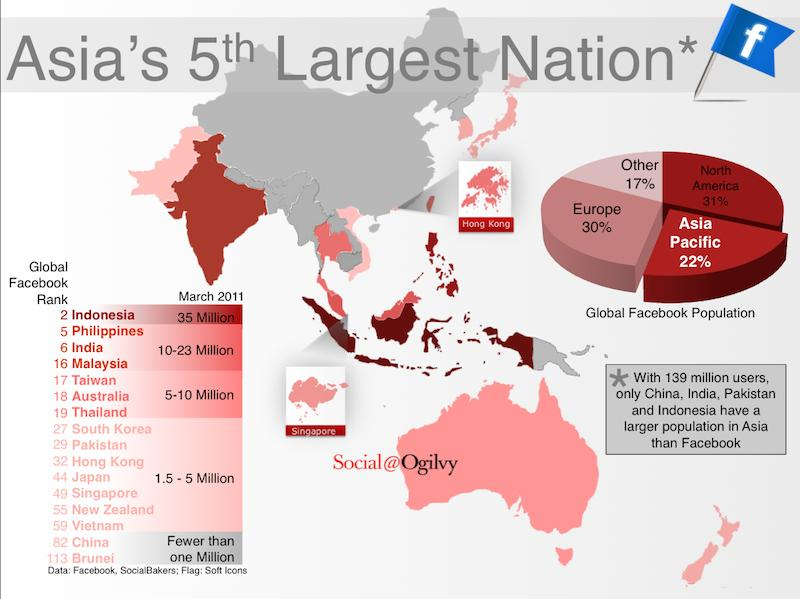List a handful of essential elements in this visual. This infographic mentions 16 global Facebook ranks. According to the data, the combined percentage of the Asia Pacific and Europe that constitutes the global Facebook population is 52%. According to the global Facebook population, a combined 53% of the Asia Pacific and North America make up the total global user base. According to data, approximately 47% of the global Facebook population is composed of users from the Other and Europe regions, taken together. 